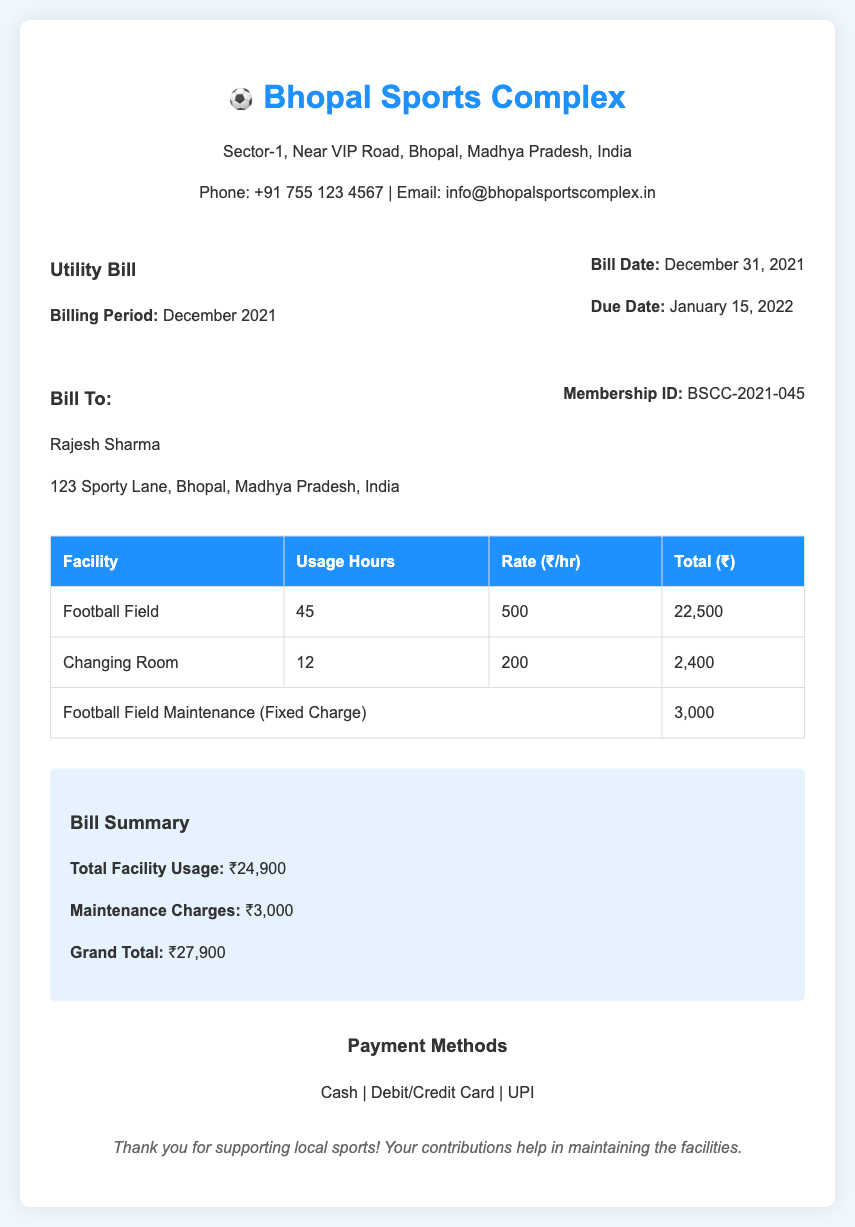What is the billing period? The billing period is specified in the document and states the month and year for which the bill is applicable.
Answer: December 2021 Who is the bill addressed to? The document includes customer details that specify the name of the individual responsible for the bill.
Answer: Rajesh Sharma What is the total for facility usage? The document provides a summary of charges for facility usage that includes the total amount for services rendered.
Answer: ₹24,900 How many hours was the Football Field used? The document specifies the number of usage hours for the Football Field, which is mentioned under facility usage details.
Answer: 45 What is the maintenance charge for the Football Field? The bill includes a line item that lists maintenance charges specifically for the football field as a fixed cost.
Answer: ₹3,000 What is the grand total amount due? The grand total is calculated based on all charges detailed in the bill, which is listed in the summary section.
Answer: ₹27,900 When is the due date for payment? The document mentions a specific date by which the payment needs to be made, which is highlighted in the billing details.
Answer: January 15, 2022 What payment methods are accepted? The document lists various payment methods available for settling the bill, providing options for the customer.
Answer: Cash, Debit/Credit Card, UPI 